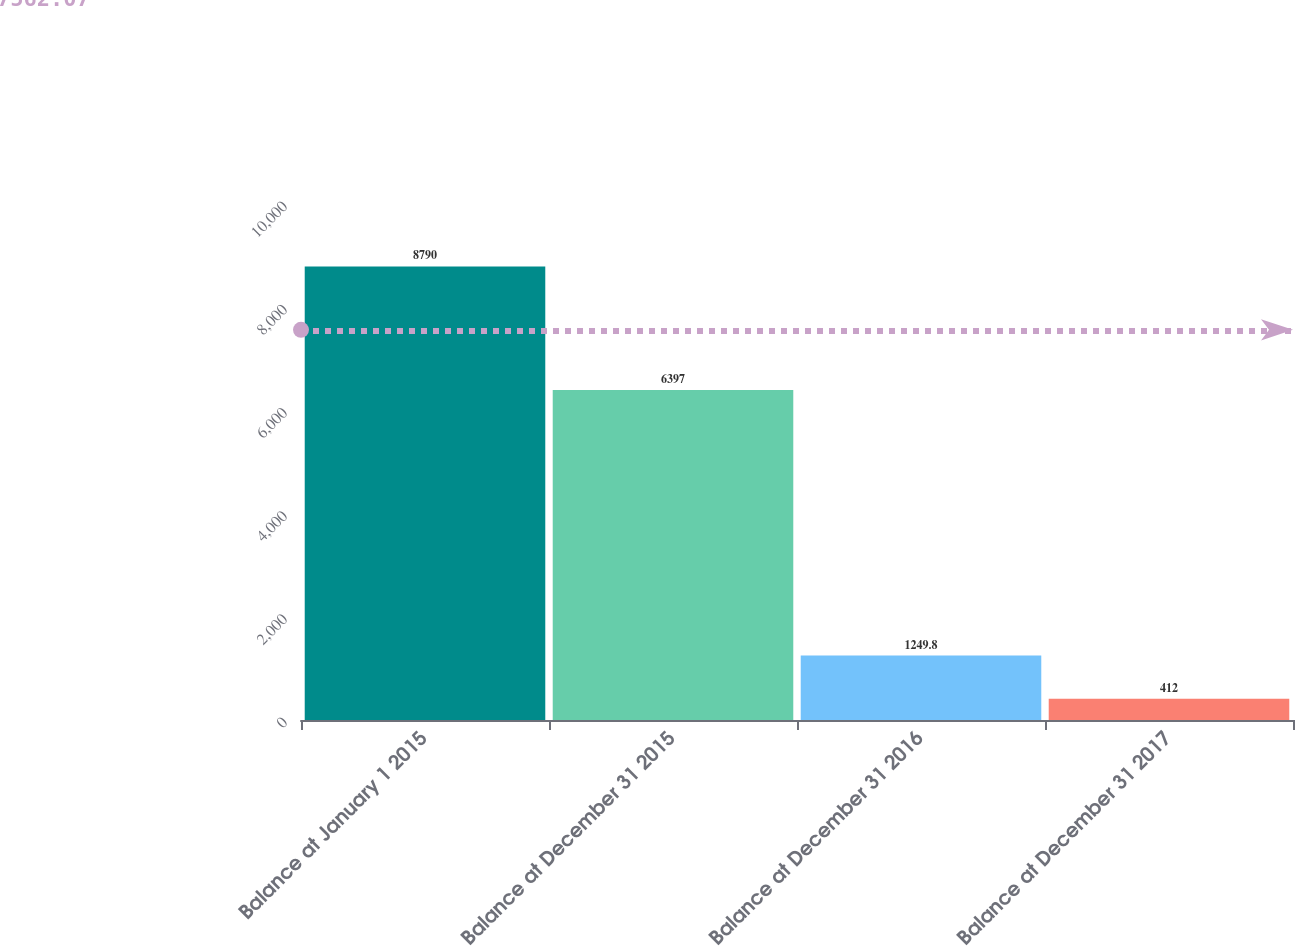<chart> <loc_0><loc_0><loc_500><loc_500><bar_chart><fcel>Balance at January 1 2015<fcel>Balance at December 31 2015<fcel>Balance at December 31 2016<fcel>Balance at December 31 2017<nl><fcel>8790<fcel>6397<fcel>1249.8<fcel>412<nl></chart> 